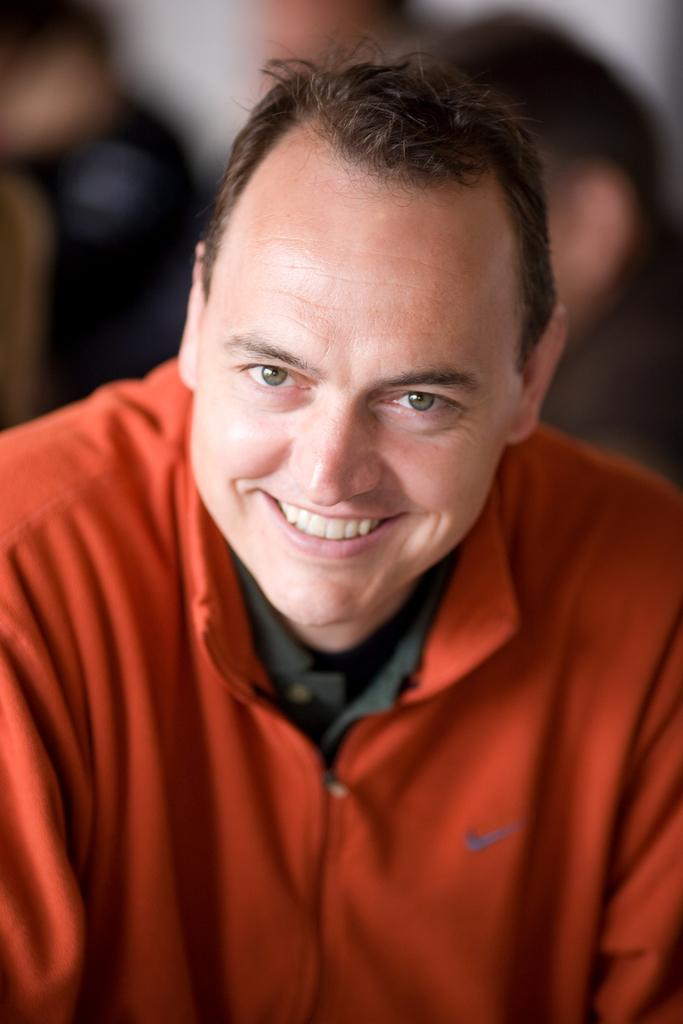What is the main subject of the image? The main subject of the image is a man standing. What is the man wearing in the image? The man is wearing a red shirt. Can you describe the background of the image? The background of the image is blurred. What type of stone can be seen in the man's hand in the image? There is no stone visible in the man's hand or anywhere else in the image. 